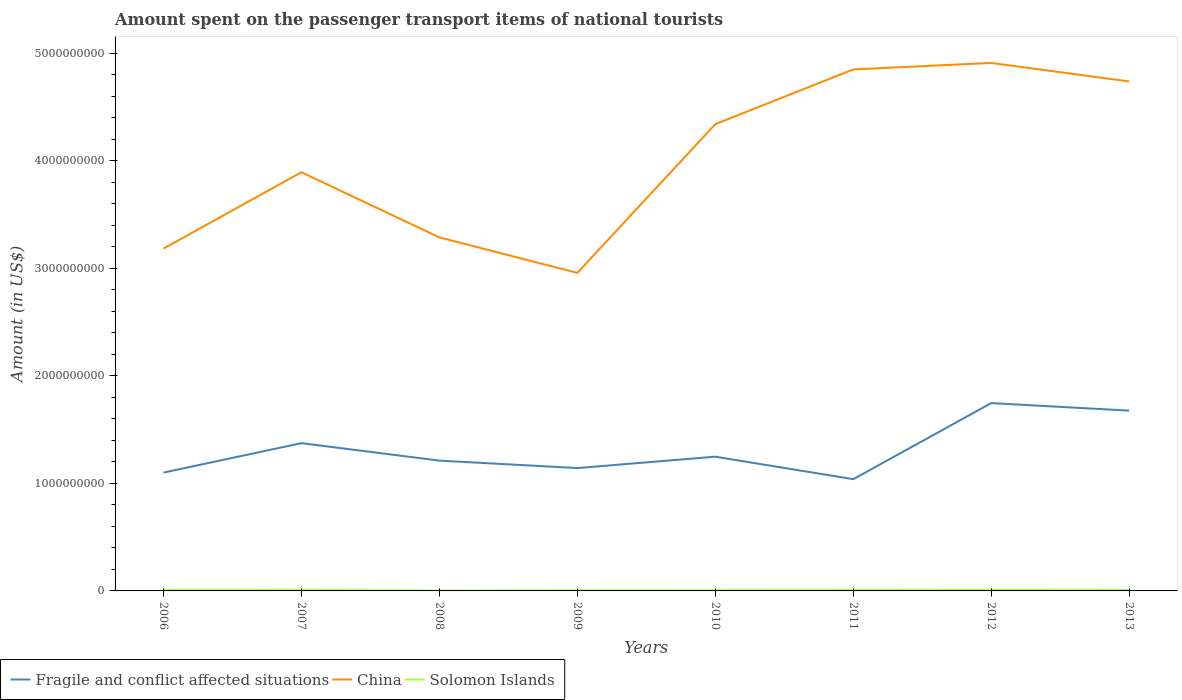Does the line corresponding to Solomon Islands intersect with the line corresponding to China?
Ensure brevity in your answer.  No. Across all years, what is the maximum amount spent on the passenger transport items of national tourists in Fragile and conflict affected situations?
Provide a succinct answer. 1.04e+09. In which year was the amount spent on the passenger transport items of national tourists in Solomon Islands maximum?
Keep it short and to the point. 2008. What is the total amount spent on the passenger transport items of national tourists in Fragile and conflict affected situations in the graph?
Offer a very short reply. 6.92e+07. What is the difference between the highest and the second highest amount spent on the passenger transport items of national tourists in Fragile and conflict affected situations?
Your response must be concise. 7.07e+08. What is the difference between the highest and the lowest amount spent on the passenger transport items of national tourists in Fragile and conflict affected situations?
Provide a succinct answer. 3. How many years are there in the graph?
Your response must be concise. 8. Does the graph contain grids?
Provide a succinct answer. No. How many legend labels are there?
Ensure brevity in your answer.  3. What is the title of the graph?
Offer a terse response. Amount spent on the passenger transport items of national tourists. Does "Iraq" appear as one of the legend labels in the graph?
Offer a terse response. No. What is the label or title of the X-axis?
Provide a short and direct response. Years. What is the label or title of the Y-axis?
Make the answer very short. Amount (in US$). What is the Amount (in US$) of Fragile and conflict affected situations in 2006?
Offer a very short reply. 1.10e+09. What is the Amount (in US$) in China in 2006?
Provide a short and direct response. 3.18e+09. What is the Amount (in US$) in Solomon Islands in 2006?
Offer a very short reply. 9.80e+06. What is the Amount (in US$) in Fragile and conflict affected situations in 2007?
Ensure brevity in your answer.  1.37e+09. What is the Amount (in US$) in China in 2007?
Your response must be concise. 3.89e+09. What is the Amount (in US$) of Solomon Islands in 2007?
Your answer should be very brief. 1.05e+07. What is the Amount (in US$) of Fragile and conflict affected situations in 2008?
Give a very brief answer. 1.21e+09. What is the Amount (in US$) of China in 2008?
Make the answer very short. 3.29e+09. What is the Amount (in US$) in Solomon Islands in 2008?
Ensure brevity in your answer.  3.70e+06. What is the Amount (in US$) of Fragile and conflict affected situations in 2009?
Your response must be concise. 1.14e+09. What is the Amount (in US$) of China in 2009?
Your answer should be very brief. 2.96e+09. What is the Amount (in US$) of Solomon Islands in 2009?
Your response must be concise. 5.90e+06. What is the Amount (in US$) in Fragile and conflict affected situations in 2010?
Offer a very short reply. 1.25e+09. What is the Amount (in US$) in China in 2010?
Provide a succinct answer. 4.34e+09. What is the Amount (in US$) in Solomon Islands in 2010?
Provide a succinct answer. 7.30e+06. What is the Amount (in US$) in Fragile and conflict affected situations in 2011?
Provide a short and direct response. 1.04e+09. What is the Amount (in US$) of China in 2011?
Your answer should be very brief. 4.85e+09. What is the Amount (in US$) of Solomon Islands in 2011?
Your answer should be compact. 8.60e+06. What is the Amount (in US$) in Fragile and conflict affected situations in 2012?
Make the answer very short. 1.75e+09. What is the Amount (in US$) in China in 2012?
Give a very brief answer. 4.91e+09. What is the Amount (in US$) in Solomon Islands in 2012?
Offer a terse response. 1.13e+07. What is the Amount (in US$) of Fragile and conflict affected situations in 2013?
Offer a very short reply. 1.68e+09. What is the Amount (in US$) of China in 2013?
Provide a succinct answer. 4.74e+09. What is the Amount (in US$) in Solomon Islands in 2013?
Your answer should be very brief. 9.00e+06. Across all years, what is the maximum Amount (in US$) in Fragile and conflict affected situations?
Provide a short and direct response. 1.75e+09. Across all years, what is the maximum Amount (in US$) of China?
Make the answer very short. 4.91e+09. Across all years, what is the maximum Amount (in US$) in Solomon Islands?
Make the answer very short. 1.13e+07. Across all years, what is the minimum Amount (in US$) of Fragile and conflict affected situations?
Provide a short and direct response. 1.04e+09. Across all years, what is the minimum Amount (in US$) in China?
Make the answer very short. 2.96e+09. Across all years, what is the minimum Amount (in US$) in Solomon Islands?
Give a very brief answer. 3.70e+06. What is the total Amount (in US$) of Fragile and conflict affected situations in the graph?
Provide a succinct answer. 1.05e+1. What is the total Amount (in US$) in China in the graph?
Provide a succinct answer. 3.22e+1. What is the total Amount (in US$) of Solomon Islands in the graph?
Offer a terse response. 6.61e+07. What is the difference between the Amount (in US$) of Fragile and conflict affected situations in 2006 and that in 2007?
Offer a very short reply. -2.74e+08. What is the difference between the Amount (in US$) in China in 2006 and that in 2007?
Provide a short and direct response. -7.10e+08. What is the difference between the Amount (in US$) of Solomon Islands in 2006 and that in 2007?
Give a very brief answer. -7.00e+05. What is the difference between the Amount (in US$) of Fragile and conflict affected situations in 2006 and that in 2008?
Offer a very short reply. -1.11e+08. What is the difference between the Amount (in US$) of China in 2006 and that in 2008?
Give a very brief answer. -1.04e+08. What is the difference between the Amount (in US$) of Solomon Islands in 2006 and that in 2008?
Give a very brief answer. 6.10e+06. What is the difference between the Amount (in US$) of Fragile and conflict affected situations in 2006 and that in 2009?
Offer a terse response. -4.22e+07. What is the difference between the Amount (in US$) of China in 2006 and that in 2009?
Your answer should be very brief. 2.26e+08. What is the difference between the Amount (in US$) in Solomon Islands in 2006 and that in 2009?
Your answer should be compact. 3.90e+06. What is the difference between the Amount (in US$) in Fragile and conflict affected situations in 2006 and that in 2010?
Offer a terse response. -1.48e+08. What is the difference between the Amount (in US$) of China in 2006 and that in 2010?
Provide a short and direct response. -1.16e+09. What is the difference between the Amount (in US$) of Solomon Islands in 2006 and that in 2010?
Your response must be concise. 2.50e+06. What is the difference between the Amount (in US$) of Fragile and conflict affected situations in 2006 and that in 2011?
Keep it short and to the point. 6.11e+07. What is the difference between the Amount (in US$) of China in 2006 and that in 2011?
Give a very brief answer. -1.67e+09. What is the difference between the Amount (in US$) of Solomon Islands in 2006 and that in 2011?
Give a very brief answer. 1.20e+06. What is the difference between the Amount (in US$) in Fragile and conflict affected situations in 2006 and that in 2012?
Provide a short and direct response. -6.46e+08. What is the difference between the Amount (in US$) of China in 2006 and that in 2012?
Offer a very short reply. -1.73e+09. What is the difference between the Amount (in US$) of Solomon Islands in 2006 and that in 2012?
Offer a terse response. -1.50e+06. What is the difference between the Amount (in US$) in Fragile and conflict affected situations in 2006 and that in 2013?
Keep it short and to the point. -5.76e+08. What is the difference between the Amount (in US$) in China in 2006 and that in 2013?
Keep it short and to the point. -1.55e+09. What is the difference between the Amount (in US$) of Fragile and conflict affected situations in 2007 and that in 2008?
Give a very brief answer. 1.62e+08. What is the difference between the Amount (in US$) in China in 2007 and that in 2008?
Your response must be concise. 6.06e+08. What is the difference between the Amount (in US$) of Solomon Islands in 2007 and that in 2008?
Provide a short and direct response. 6.80e+06. What is the difference between the Amount (in US$) in Fragile and conflict affected situations in 2007 and that in 2009?
Offer a very short reply. 2.32e+08. What is the difference between the Amount (in US$) of China in 2007 and that in 2009?
Offer a terse response. 9.36e+08. What is the difference between the Amount (in US$) in Solomon Islands in 2007 and that in 2009?
Make the answer very short. 4.60e+06. What is the difference between the Amount (in US$) in Fragile and conflict affected situations in 2007 and that in 2010?
Your answer should be compact. 1.26e+08. What is the difference between the Amount (in US$) of China in 2007 and that in 2010?
Make the answer very short. -4.47e+08. What is the difference between the Amount (in US$) in Solomon Islands in 2007 and that in 2010?
Give a very brief answer. 3.20e+06. What is the difference between the Amount (in US$) in Fragile and conflict affected situations in 2007 and that in 2011?
Keep it short and to the point. 3.35e+08. What is the difference between the Amount (in US$) of China in 2007 and that in 2011?
Make the answer very short. -9.56e+08. What is the difference between the Amount (in US$) in Solomon Islands in 2007 and that in 2011?
Provide a succinct answer. 1.90e+06. What is the difference between the Amount (in US$) of Fragile and conflict affected situations in 2007 and that in 2012?
Your response must be concise. -3.72e+08. What is the difference between the Amount (in US$) of China in 2007 and that in 2012?
Provide a short and direct response. -1.02e+09. What is the difference between the Amount (in US$) in Solomon Islands in 2007 and that in 2012?
Keep it short and to the point. -8.00e+05. What is the difference between the Amount (in US$) of Fragile and conflict affected situations in 2007 and that in 2013?
Your answer should be very brief. -3.02e+08. What is the difference between the Amount (in US$) in China in 2007 and that in 2013?
Your response must be concise. -8.44e+08. What is the difference between the Amount (in US$) of Solomon Islands in 2007 and that in 2013?
Offer a very short reply. 1.50e+06. What is the difference between the Amount (in US$) of Fragile and conflict affected situations in 2008 and that in 2009?
Offer a terse response. 6.92e+07. What is the difference between the Amount (in US$) of China in 2008 and that in 2009?
Your response must be concise. 3.30e+08. What is the difference between the Amount (in US$) of Solomon Islands in 2008 and that in 2009?
Offer a very short reply. -2.20e+06. What is the difference between the Amount (in US$) of Fragile and conflict affected situations in 2008 and that in 2010?
Your response must be concise. -3.64e+07. What is the difference between the Amount (in US$) of China in 2008 and that in 2010?
Your answer should be compact. -1.05e+09. What is the difference between the Amount (in US$) in Solomon Islands in 2008 and that in 2010?
Ensure brevity in your answer.  -3.60e+06. What is the difference between the Amount (in US$) in Fragile and conflict affected situations in 2008 and that in 2011?
Your answer should be very brief. 1.73e+08. What is the difference between the Amount (in US$) in China in 2008 and that in 2011?
Offer a terse response. -1.56e+09. What is the difference between the Amount (in US$) of Solomon Islands in 2008 and that in 2011?
Your response must be concise. -4.90e+06. What is the difference between the Amount (in US$) of Fragile and conflict affected situations in 2008 and that in 2012?
Keep it short and to the point. -5.35e+08. What is the difference between the Amount (in US$) of China in 2008 and that in 2012?
Your answer should be compact. -1.62e+09. What is the difference between the Amount (in US$) in Solomon Islands in 2008 and that in 2012?
Keep it short and to the point. -7.60e+06. What is the difference between the Amount (in US$) in Fragile and conflict affected situations in 2008 and that in 2013?
Provide a short and direct response. -4.65e+08. What is the difference between the Amount (in US$) in China in 2008 and that in 2013?
Offer a terse response. -1.45e+09. What is the difference between the Amount (in US$) in Solomon Islands in 2008 and that in 2013?
Offer a very short reply. -5.30e+06. What is the difference between the Amount (in US$) of Fragile and conflict affected situations in 2009 and that in 2010?
Keep it short and to the point. -1.06e+08. What is the difference between the Amount (in US$) of China in 2009 and that in 2010?
Ensure brevity in your answer.  -1.38e+09. What is the difference between the Amount (in US$) of Solomon Islands in 2009 and that in 2010?
Provide a succinct answer. -1.40e+06. What is the difference between the Amount (in US$) of Fragile and conflict affected situations in 2009 and that in 2011?
Your response must be concise. 1.03e+08. What is the difference between the Amount (in US$) in China in 2009 and that in 2011?
Give a very brief answer. -1.89e+09. What is the difference between the Amount (in US$) of Solomon Islands in 2009 and that in 2011?
Your answer should be very brief. -2.70e+06. What is the difference between the Amount (in US$) in Fragile and conflict affected situations in 2009 and that in 2012?
Provide a succinct answer. -6.04e+08. What is the difference between the Amount (in US$) in China in 2009 and that in 2012?
Offer a very short reply. -1.95e+09. What is the difference between the Amount (in US$) in Solomon Islands in 2009 and that in 2012?
Your answer should be compact. -5.40e+06. What is the difference between the Amount (in US$) in Fragile and conflict affected situations in 2009 and that in 2013?
Keep it short and to the point. -5.34e+08. What is the difference between the Amount (in US$) in China in 2009 and that in 2013?
Your answer should be compact. -1.78e+09. What is the difference between the Amount (in US$) in Solomon Islands in 2009 and that in 2013?
Keep it short and to the point. -3.10e+06. What is the difference between the Amount (in US$) in Fragile and conflict affected situations in 2010 and that in 2011?
Give a very brief answer. 2.09e+08. What is the difference between the Amount (in US$) in China in 2010 and that in 2011?
Your answer should be compact. -5.09e+08. What is the difference between the Amount (in US$) in Solomon Islands in 2010 and that in 2011?
Provide a succinct answer. -1.30e+06. What is the difference between the Amount (in US$) of Fragile and conflict affected situations in 2010 and that in 2012?
Your response must be concise. -4.98e+08. What is the difference between the Amount (in US$) in China in 2010 and that in 2012?
Give a very brief answer. -5.69e+08. What is the difference between the Amount (in US$) of Solomon Islands in 2010 and that in 2012?
Give a very brief answer. -4.00e+06. What is the difference between the Amount (in US$) in Fragile and conflict affected situations in 2010 and that in 2013?
Your answer should be compact. -4.28e+08. What is the difference between the Amount (in US$) in China in 2010 and that in 2013?
Give a very brief answer. -3.97e+08. What is the difference between the Amount (in US$) of Solomon Islands in 2010 and that in 2013?
Ensure brevity in your answer.  -1.70e+06. What is the difference between the Amount (in US$) in Fragile and conflict affected situations in 2011 and that in 2012?
Ensure brevity in your answer.  -7.07e+08. What is the difference between the Amount (in US$) of China in 2011 and that in 2012?
Provide a short and direct response. -6.00e+07. What is the difference between the Amount (in US$) in Solomon Islands in 2011 and that in 2012?
Provide a short and direct response. -2.70e+06. What is the difference between the Amount (in US$) in Fragile and conflict affected situations in 2011 and that in 2013?
Provide a short and direct response. -6.37e+08. What is the difference between the Amount (in US$) in China in 2011 and that in 2013?
Keep it short and to the point. 1.12e+08. What is the difference between the Amount (in US$) in Solomon Islands in 2011 and that in 2013?
Your answer should be compact. -4.00e+05. What is the difference between the Amount (in US$) in Fragile and conflict affected situations in 2012 and that in 2013?
Offer a very short reply. 7.01e+07. What is the difference between the Amount (in US$) of China in 2012 and that in 2013?
Give a very brief answer. 1.72e+08. What is the difference between the Amount (in US$) in Solomon Islands in 2012 and that in 2013?
Provide a succinct answer. 2.30e+06. What is the difference between the Amount (in US$) in Fragile and conflict affected situations in 2006 and the Amount (in US$) in China in 2007?
Provide a short and direct response. -2.79e+09. What is the difference between the Amount (in US$) in Fragile and conflict affected situations in 2006 and the Amount (in US$) in Solomon Islands in 2007?
Provide a short and direct response. 1.09e+09. What is the difference between the Amount (in US$) in China in 2006 and the Amount (in US$) in Solomon Islands in 2007?
Make the answer very short. 3.17e+09. What is the difference between the Amount (in US$) of Fragile and conflict affected situations in 2006 and the Amount (in US$) of China in 2008?
Your answer should be very brief. -2.19e+09. What is the difference between the Amount (in US$) of Fragile and conflict affected situations in 2006 and the Amount (in US$) of Solomon Islands in 2008?
Provide a short and direct response. 1.10e+09. What is the difference between the Amount (in US$) in China in 2006 and the Amount (in US$) in Solomon Islands in 2008?
Give a very brief answer. 3.18e+09. What is the difference between the Amount (in US$) of Fragile and conflict affected situations in 2006 and the Amount (in US$) of China in 2009?
Your response must be concise. -1.86e+09. What is the difference between the Amount (in US$) in Fragile and conflict affected situations in 2006 and the Amount (in US$) in Solomon Islands in 2009?
Give a very brief answer. 1.09e+09. What is the difference between the Amount (in US$) of China in 2006 and the Amount (in US$) of Solomon Islands in 2009?
Make the answer very short. 3.18e+09. What is the difference between the Amount (in US$) in Fragile and conflict affected situations in 2006 and the Amount (in US$) in China in 2010?
Your answer should be very brief. -3.24e+09. What is the difference between the Amount (in US$) of Fragile and conflict affected situations in 2006 and the Amount (in US$) of Solomon Islands in 2010?
Offer a terse response. 1.09e+09. What is the difference between the Amount (in US$) in China in 2006 and the Amount (in US$) in Solomon Islands in 2010?
Your response must be concise. 3.18e+09. What is the difference between the Amount (in US$) of Fragile and conflict affected situations in 2006 and the Amount (in US$) of China in 2011?
Make the answer very short. -3.75e+09. What is the difference between the Amount (in US$) of Fragile and conflict affected situations in 2006 and the Amount (in US$) of Solomon Islands in 2011?
Keep it short and to the point. 1.09e+09. What is the difference between the Amount (in US$) in China in 2006 and the Amount (in US$) in Solomon Islands in 2011?
Offer a terse response. 3.17e+09. What is the difference between the Amount (in US$) in Fragile and conflict affected situations in 2006 and the Amount (in US$) in China in 2012?
Provide a succinct answer. -3.81e+09. What is the difference between the Amount (in US$) of Fragile and conflict affected situations in 2006 and the Amount (in US$) of Solomon Islands in 2012?
Make the answer very short. 1.09e+09. What is the difference between the Amount (in US$) in China in 2006 and the Amount (in US$) in Solomon Islands in 2012?
Provide a succinct answer. 3.17e+09. What is the difference between the Amount (in US$) of Fragile and conflict affected situations in 2006 and the Amount (in US$) of China in 2013?
Your response must be concise. -3.64e+09. What is the difference between the Amount (in US$) in Fragile and conflict affected situations in 2006 and the Amount (in US$) in Solomon Islands in 2013?
Your answer should be very brief. 1.09e+09. What is the difference between the Amount (in US$) of China in 2006 and the Amount (in US$) of Solomon Islands in 2013?
Make the answer very short. 3.17e+09. What is the difference between the Amount (in US$) of Fragile and conflict affected situations in 2007 and the Amount (in US$) of China in 2008?
Your answer should be compact. -1.91e+09. What is the difference between the Amount (in US$) of Fragile and conflict affected situations in 2007 and the Amount (in US$) of Solomon Islands in 2008?
Keep it short and to the point. 1.37e+09. What is the difference between the Amount (in US$) of China in 2007 and the Amount (in US$) of Solomon Islands in 2008?
Provide a short and direct response. 3.89e+09. What is the difference between the Amount (in US$) in Fragile and conflict affected situations in 2007 and the Amount (in US$) in China in 2009?
Offer a very short reply. -1.58e+09. What is the difference between the Amount (in US$) of Fragile and conflict affected situations in 2007 and the Amount (in US$) of Solomon Islands in 2009?
Your answer should be very brief. 1.37e+09. What is the difference between the Amount (in US$) of China in 2007 and the Amount (in US$) of Solomon Islands in 2009?
Keep it short and to the point. 3.89e+09. What is the difference between the Amount (in US$) of Fragile and conflict affected situations in 2007 and the Amount (in US$) of China in 2010?
Keep it short and to the point. -2.97e+09. What is the difference between the Amount (in US$) in Fragile and conflict affected situations in 2007 and the Amount (in US$) in Solomon Islands in 2010?
Offer a very short reply. 1.37e+09. What is the difference between the Amount (in US$) of China in 2007 and the Amount (in US$) of Solomon Islands in 2010?
Your answer should be very brief. 3.89e+09. What is the difference between the Amount (in US$) in Fragile and conflict affected situations in 2007 and the Amount (in US$) in China in 2011?
Ensure brevity in your answer.  -3.48e+09. What is the difference between the Amount (in US$) of Fragile and conflict affected situations in 2007 and the Amount (in US$) of Solomon Islands in 2011?
Your answer should be very brief. 1.37e+09. What is the difference between the Amount (in US$) in China in 2007 and the Amount (in US$) in Solomon Islands in 2011?
Offer a very short reply. 3.88e+09. What is the difference between the Amount (in US$) of Fragile and conflict affected situations in 2007 and the Amount (in US$) of China in 2012?
Your answer should be compact. -3.54e+09. What is the difference between the Amount (in US$) of Fragile and conflict affected situations in 2007 and the Amount (in US$) of Solomon Islands in 2012?
Give a very brief answer. 1.36e+09. What is the difference between the Amount (in US$) in China in 2007 and the Amount (in US$) in Solomon Islands in 2012?
Your response must be concise. 3.88e+09. What is the difference between the Amount (in US$) of Fragile and conflict affected situations in 2007 and the Amount (in US$) of China in 2013?
Your answer should be compact. -3.36e+09. What is the difference between the Amount (in US$) in Fragile and conflict affected situations in 2007 and the Amount (in US$) in Solomon Islands in 2013?
Your answer should be compact. 1.36e+09. What is the difference between the Amount (in US$) of China in 2007 and the Amount (in US$) of Solomon Islands in 2013?
Make the answer very short. 3.88e+09. What is the difference between the Amount (in US$) in Fragile and conflict affected situations in 2008 and the Amount (in US$) in China in 2009?
Provide a short and direct response. -1.75e+09. What is the difference between the Amount (in US$) in Fragile and conflict affected situations in 2008 and the Amount (in US$) in Solomon Islands in 2009?
Your answer should be compact. 1.21e+09. What is the difference between the Amount (in US$) of China in 2008 and the Amount (in US$) of Solomon Islands in 2009?
Your answer should be very brief. 3.28e+09. What is the difference between the Amount (in US$) in Fragile and conflict affected situations in 2008 and the Amount (in US$) in China in 2010?
Keep it short and to the point. -3.13e+09. What is the difference between the Amount (in US$) of Fragile and conflict affected situations in 2008 and the Amount (in US$) of Solomon Islands in 2010?
Give a very brief answer. 1.20e+09. What is the difference between the Amount (in US$) in China in 2008 and the Amount (in US$) in Solomon Islands in 2010?
Give a very brief answer. 3.28e+09. What is the difference between the Amount (in US$) in Fragile and conflict affected situations in 2008 and the Amount (in US$) in China in 2011?
Give a very brief answer. -3.64e+09. What is the difference between the Amount (in US$) in Fragile and conflict affected situations in 2008 and the Amount (in US$) in Solomon Islands in 2011?
Give a very brief answer. 1.20e+09. What is the difference between the Amount (in US$) in China in 2008 and the Amount (in US$) in Solomon Islands in 2011?
Make the answer very short. 3.28e+09. What is the difference between the Amount (in US$) in Fragile and conflict affected situations in 2008 and the Amount (in US$) in China in 2012?
Provide a short and direct response. -3.70e+09. What is the difference between the Amount (in US$) of Fragile and conflict affected situations in 2008 and the Amount (in US$) of Solomon Islands in 2012?
Give a very brief answer. 1.20e+09. What is the difference between the Amount (in US$) of China in 2008 and the Amount (in US$) of Solomon Islands in 2012?
Provide a short and direct response. 3.28e+09. What is the difference between the Amount (in US$) of Fragile and conflict affected situations in 2008 and the Amount (in US$) of China in 2013?
Keep it short and to the point. -3.53e+09. What is the difference between the Amount (in US$) in Fragile and conflict affected situations in 2008 and the Amount (in US$) in Solomon Islands in 2013?
Your response must be concise. 1.20e+09. What is the difference between the Amount (in US$) in China in 2008 and the Amount (in US$) in Solomon Islands in 2013?
Give a very brief answer. 3.28e+09. What is the difference between the Amount (in US$) of Fragile and conflict affected situations in 2009 and the Amount (in US$) of China in 2010?
Provide a short and direct response. -3.20e+09. What is the difference between the Amount (in US$) of Fragile and conflict affected situations in 2009 and the Amount (in US$) of Solomon Islands in 2010?
Provide a succinct answer. 1.14e+09. What is the difference between the Amount (in US$) in China in 2009 and the Amount (in US$) in Solomon Islands in 2010?
Your answer should be compact. 2.95e+09. What is the difference between the Amount (in US$) of Fragile and conflict affected situations in 2009 and the Amount (in US$) of China in 2011?
Give a very brief answer. -3.71e+09. What is the difference between the Amount (in US$) of Fragile and conflict affected situations in 2009 and the Amount (in US$) of Solomon Islands in 2011?
Keep it short and to the point. 1.13e+09. What is the difference between the Amount (in US$) in China in 2009 and the Amount (in US$) in Solomon Islands in 2011?
Give a very brief answer. 2.95e+09. What is the difference between the Amount (in US$) of Fragile and conflict affected situations in 2009 and the Amount (in US$) of China in 2012?
Give a very brief answer. -3.77e+09. What is the difference between the Amount (in US$) of Fragile and conflict affected situations in 2009 and the Amount (in US$) of Solomon Islands in 2012?
Your response must be concise. 1.13e+09. What is the difference between the Amount (in US$) of China in 2009 and the Amount (in US$) of Solomon Islands in 2012?
Keep it short and to the point. 2.95e+09. What is the difference between the Amount (in US$) of Fragile and conflict affected situations in 2009 and the Amount (in US$) of China in 2013?
Give a very brief answer. -3.59e+09. What is the difference between the Amount (in US$) in Fragile and conflict affected situations in 2009 and the Amount (in US$) in Solomon Islands in 2013?
Keep it short and to the point. 1.13e+09. What is the difference between the Amount (in US$) in China in 2009 and the Amount (in US$) in Solomon Islands in 2013?
Offer a very short reply. 2.95e+09. What is the difference between the Amount (in US$) in Fragile and conflict affected situations in 2010 and the Amount (in US$) in China in 2011?
Ensure brevity in your answer.  -3.60e+09. What is the difference between the Amount (in US$) of Fragile and conflict affected situations in 2010 and the Amount (in US$) of Solomon Islands in 2011?
Provide a succinct answer. 1.24e+09. What is the difference between the Amount (in US$) in China in 2010 and the Amount (in US$) in Solomon Islands in 2011?
Provide a succinct answer. 4.33e+09. What is the difference between the Amount (in US$) in Fragile and conflict affected situations in 2010 and the Amount (in US$) in China in 2012?
Offer a terse response. -3.66e+09. What is the difference between the Amount (in US$) of Fragile and conflict affected situations in 2010 and the Amount (in US$) of Solomon Islands in 2012?
Your answer should be compact. 1.24e+09. What is the difference between the Amount (in US$) of China in 2010 and the Amount (in US$) of Solomon Islands in 2012?
Make the answer very short. 4.33e+09. What is the difference between the Amount (in US$) of Fragile and conflict affected situations in 2010 and the Amount (in US$) of China in 2013?
Make the answer very short. -3.49e+09. What is the difference between the Amount (in US$) in Fragile and conflict affected situations in 2010 and the Amount (in US$) in Solomon Islands in 2013?
Provide a short and direct response. 1.24e+09. What is the difference between the Amount (in US$) of China in 2010 and the Amount (in US$) of Solomon Islands in 2013?
Make the answer very short. 4.33e+09. What is the difference between the Amount (in US$) of Fragile and conflict affected situations in 2011 and the Amount (in US$) of China in 2012?
Your answer should be compact. -3.87e+09. What is the difference between the Amount (in US$) in Fragile and conflict affected situations in 2011 and the Amount (in US$) in Solomon Islands in 2012?
Provide a succinct answer. 1.03e+09. What is the difference between the Amount (in US$) in China in 2011 and the Amount (in US$) in Solomon Islands in 2012?
Keep it short and to the point. 4.84e+09. What is the difference between the Amount (in US$) in Fragile and conflict affected situations in 2011 and the Amount (in US$) in China in 2013?
Make the answer very short. -3.70e+09. What is the difference between the Amount (in US$) in Fragile and conflict affected situations in 2011 and the Amount (in US$) in Solomon Islands in 2013?
Provide a short and direct response. 1.03e+09. What is the difference between the Amount (in US$) in China in 2011 and the Amount (in US$) in Solomon Islands in 2013?
Your answer should be compact. 4.84e+09. What is the difference between the Amount (in US$) of Fragile and conflict affected situations in 2012 and the Amount (in US$) of China in 2013?
Make the answer very short. -2.99e+09. What is the difference between the Amount (in US$) in Fragile and conflict affected situations in 2012 and the Amount (in US$) in Solomon Islands in 2013?
Your answer should be very brief. 1.74e+09. What is the difference between the Amount (in US$) of China in 2012 and the Amount (in US$) of Solomon Islands in 2013?
Offer a very short reply. 4.90e+09. What is the average Amount (in US$) of Fragile and conflict affected situations per year?
Ensure brevity in your answer.  1.32e+09. What is the average Amount (in US$) in China per year?
Your response must be concise. 4.02e+09. What is the average Amount (in US$) of Solomon Islands per year?
Give a very brief answer. 8.26e+06. In the year 2006, what is the difference between the Amount (in US$) of Fragile and conflict affected situations and Amount (in US$) of China?
Your answer should be very brief. -2.08e+09. In the year 2006, what is the difference between the Amount (in US$) in Fragile and conflict affected situations and Amount (in US$) in Solomon Islands?
Ensure brevity in your answer.  1.09e+09. In the year 2006, what is the difference between the Amount (in US$) of China and Amount (in US$) of Solomon Islands?
Your answer should be compact. 3.17e+09. In the year 2007, what is the difference between the Amount (in US$) in Fragile and conflict affected situations and Amount (in US$) in China?
Keep it short and to the point. -2.52e+09. In the year 2007, what is the difference between the Amount (in US$) in Fragile and conflict affected situations and Amount (in US$) in Solomon Islands?
Keep it short and to the point. 1.36e+09. In the year 2007, what is the difference between the Amount (in US$) in China and Amount (in US$) in Solomon Islands?
Make the answer very short. 3.88e+09. In the year 2008, what is the difference between the Amount (in US$) of Fragile and conflict affected situations and Amount (in US$) of China?
Your answer should be very brief. -2.08e+09. In the year 2008, what is the difference between the Amount (in US$) of Fragile and conflict affected situations and Amount (in US$) of Solomon Islands?
Provide a succinct answer. 1.21e+09. In the year 2008, what is the difference between the Amount (in US$) of China and Amount (in US$) of Solomon Islands?
Your answer should be very brief. 3.28e+09. In the year 2009, what is the difference between the Amount (in US$) in Fragile and conflict affected situations and Amount (in US$) in China?
Your answer should be very brief. -1.81e+09. In the year 2009, what is the difference between the Amount (in US$) in Fragile and conflict affected situations and Amount (in US$) in Solomon Islands?
Offer a terse response. 1.14e+09. In the year 2009, what is the difference between the Amount (in US$) in China and Amount (in US$) in Solomon Islands?
Offer a terse response. 2.95e+09. In the year 2010, what is the difference between the Amount (in US$) of Fragile and conflict affected situations and Amount (in US$) of China?
Your response must be concise. -3.09e+09. In the year 2010, what is the difference between the Amount (in US$) in Fragile and conflict affected situations and Amount (in US$) in Solomon Islands?
Your answer should be compact. 1.24e+09. In the year 2010, what is the difference between the Amount (in US$) in China and Amount (in US$) in Solomon Islands?
Your answer should be compact. 4.33e+09. In the year 2011, what is the difference between the Amount (in US$) in Fragile and conflict affected situations and Amount (in US$) in China?
Ensure brevity in your answer.  -3.81e+09. In the year 2011, what is the difference between the Amount (in US$) in Fragile and conflict affected situations and Amount (in US$) in Solomon Islands?
Offer a very short reply. 1.03e+09. In the year 2011, what is the difference between the Amount (in US$) of China and Amount (in US$) of Solomon Islands?
Offer a very short reply. 4.84e+09. In the year 2012, what is the difference between the Amount (in US$) in Fragile and conflict affected situations and Amount (in US$) in China?
Offer a very short reply. -3.16e+09. In the year 2012, what is the difference between the Amount (in US$) of Fragile and conflict affected situations and Amount (in US$) of Solomon Islands?
Offer a very short reply. 1.74e+09. In the year 2012, what is the difference between the Amount (in US$) of China and Amount (in US$) of Solomon Islands?
Provide a short and direct response. 4.90e+09. In the year 2013, what is the difference between the Amount (in US$) in Fragile and conflict affected situations and Amount (in US$) in China?
Provide a succinct answer. -3.06e+09. In the year 2013, what is the difference between the Amount (in US$) in Fragile and conflict affected situations and Amount (in US$) in Solomon Islands?
Offer a very short reply. 1.67e+09. In the year 2013, what is the difference between the Amount (in US$) of China and Amount (in US$) of Solomon Islands?
Provide a short and direct response. 4.73e+09. What is the ratio of the Amount (in US$) in Fragile and conflict affected situations in 2006 to that in 2007?
Your answer should be very brief. 0.8. What is the ratio of the Amount (in US$) in China in 2006 to that in 2007?
Offer a terse response. 0.82. What is the ratio of the Amount (in US$) of Fragile and conflict affected situations in 2006 to that in 2008?
Offer a very short reply. 0.91. What is the ratio of the Amount (in US$) in China in 2006 to that in 2008?
Keep it short and to the point. 0.97. What is the ratio of the Amount (in US$) of Solomon Islands in 2006 to that in 2008?
Your answer should be very brief. 2.65. What is the ratio of the Amount (in US$) in Fragile and conflict affected situations in 2006 to that in 2009?
Ensure brevity in your answer.  0.96. What is the ratio of the Amount (in US$) in China in 2006 to that in 2009?
Your answer should be compact. 1.08. What is the ratio of the Amount (in US$) of Solomon Islands in 2006 to that in 2009?
Make the answer very short. 1.66. What is the ratio of the Amount (in US$) in Fragile and conflict affected situations in 2006 to that in 2010?
Your answer should be very brief. 0.88. What is the ratio of the Amount (in US$) in China in 2006 to that in 2010?
Keep it short and to the point. 0.73. What is the ratio of the Amount (in US$) of Solomon Islands in 2006 to that in 2010?
Give a very brief answer. 1.34. What is the ratio of the Amount (in US$) of Fragile and conflict affected situations in 2006 to that in 2011?
Provide a succinct answer. 1.06. What is the ratio of the Amount (in US$) in China in 2006 to that in 2011?
Ensure brevity in your answer.  0.66. What is the ratio of the Amount (in US$) of Solomon Islands in 2006 to that in 2011?
Your answer should be compact. 1.14. What is the ratio of the Amount (in US$) of Fragile and conflict affected situations in 2006 to that in 2012?
Your answer should be very brief. 0.63. What is the ratio of the Amount (in US$) of China in 2006 to that in 2012?
Ensure brevity in your answer.  0.65. What is the ratio of the Amount (in US$) in Solomon Islands in 2006 to that in 2012?
Provide a short and direct response. 0.87. What is the ratio of the Amount (in US$) in Fragile and conflict affected situations in 2006 to that in 2013?
Offer a terse response. 0.66. What is the ratio of the Amount (in US$) in China in 2006 to that in 2013?
Give a very brief answer. 0.67. What is the ratio of the Amount (in US$) in Solomon Islands in 2006 to that in 2013?
Give a very brief answer. 1.09. What is the ratio of the Amount (in US$) of Fragile and conflict affected situations in 2007 to that in 2008?
Keep it short and to the point. 1.13. What is the ratio of the Amount (in US$) of China in 2007 to that in 2008?
Provide a short and direct response. 1.18. What is the ratio of the Amount (in US$) of Solomon Islands in 2007 to that in 2008?
Provide a short and direct response. 2.84. What is the ratio of the Amount (in US$) of Fragile and conflict affected situations in 2007 to that in 2009?
Give a very brief answer. 1.2. What is the ratio of the Amount (in US$) of China in 2007 to that in 2009?
Your answer should be very brief. 1.32. What is the ratio of the Amount (in US$) in Solomon Islands in 2007 to that in 2009?
Your answer should be very brief. 1.78. What is the ratio of the Amount (in US$) in Fragile and conflict affected situations in 2007 to that in 2010?
Provide a succinct answer. 1.1. What is the ratio of the Amount (in US$) of China in 2007 to that in 2010?
Your answer should be very brief. 0.9. What is the ratio of the Amount (in US$) in Solomon Islands in 2007 to that in 2010?
Ensure brevity in your answer.  1.44. What is the ratio of the Amount (in US$) in Fragile and conflict affected situations in 2007 to that in 2011?
Provide a succinct answer. 1.32. What is the ratio of the Amount (in US$) of China in 2007 to that in 2011?
Keep it short and to the point. 0.8. What is the ratio of the Amount (in US$) of Solomon Islands in 2007 to that in 2011?
Provide a succinct answer. 1.22. What is the ratio of the Amount (in US$) in Fragile and conflict affected situations in 2007 to that in 2012?
Keep it short and to the point. 0.79. What is the ratio of the Amount (in US$) of China in 2007 to that in 2012?
Offer a very short reply. 0.79. What is the ratio of the Amount (in US$) of Solomon Islands in 2007 to that in 2012?
Your response must be concise. 0.93. What is the ratio of the Amount (in US$) in Fragile and conflict affected situations in 2007 to that in 2013?
Keep it short and to the point. 0.82. What is the ratio of the Amount (in US$) of China in 2007 to that in 2013?
Offer a terse response. 0.82. What is the ratio of the Amount (in US$) of Solomon Islands in 2007 to that in 2013?
Provide a succinct answer. 1.17. What is the ratio of the Amount (in US$) of Fragile and conflict affected situations in 2008 to that in 2009?
Make the answer very short. 1.06. What is the ratio of the Amount (in US$) in China in 2008 to that in 2009?
Offer a very short reply. 1.11. What is the ratio of the Amount (in US$) in Solomon Islands in 2008 to that in 2009?
Keep it short and to the point. 0.63. What is the ratio of the Amount (in US$) in Fragile and conflict affected situations in 2008 to that in 2010?
Provide a short and direct response. 0.97. What is the ratio of the Amount (in US$) in China in 2008 to that in 2010?
Provide a succinct answer. 0.76. What is the ratio of the Amount (in US$) in Solomon Islands in 2008 to that in 2010?
Provide a short and direct response. 0.51. What is the ratio of the Amount (in US$) of Fragile and conflict affected situations in 2008 to that in 2011?
Keep it short and to the point. 1.17. What is the ratio of the Amount (in US$) of China in 2008 to that in 2011?
Your answer should be compact. 0.68. What is the ratio of the Amount (in US$) in Solomon Islands in 2008 to that in 2011?
Your answer should be compact. 0.43. What is the ratio of the Amount (in US$) of Fragile and conflict affected situations in 2008 to that in 2012?
Your answer should be very brief. 0.69. What is the ratio of the Amount (in US$) of China in 2008 to that in 2012?
Your answer should be compact. 0.67. What is the ratio of the Amount (in US$) of Solomon Islands in 2008 to that in 2012?
Make the answer very short. 0.33. What is the ratio of the Amount (in US$) in Fragile and conflict affected situations in 2008 to that in 2013?
Ensure brevity in your answer.  0.72. What is the ratio of the Amount (in US$) in China in 2008 to that in 2013?
Make the answer very short. 0.69. What is the ratio of the Amount (in US$) of Solomon Islands in 2008 to that in 2013?
Ensure brevity in your answer.  0.41. What is the ratio of the Amount (in US$) in Fragile and conflict affected situations in 2009 to that in 2010?
Your answer should be compact. 0.92. What is the ratio of the Amount (in US$) of China in 2009 to that in 2010?
Your answer should be very brief. 0.68. What is the ratio of the Amount (in US$) in Solomon Islands in 2009 to that in 2010?
Your response must be concise. 0.81. What is the ratio of the Amount (in US$) of Fragile and conflict affected situations in 2009 to that in 2011?
Give a very brief answer. 1.1. What is the ratio of the Amount (in US$) of China in 2009 to that in 2011?
Ensure brevity in your answer.  0.61. What is the ratio of the Amount (in US$) in Solomon Islands in 2009 to that in 2011?
Give a very brief answer. 0.69. What is the ratio of the Amount (in US$) of Fragile and conflict affected situations in 2009 to that in 2012?
Ensure brevity in your answer.  0.65. What is the ratio of the Amount (in US$) in China in 2009 to that in 2012?
Your response must be concise. 0.6. What is the ratio of the Amount (in US$) in Solomon Islands in 2009 to that in 2012?
Ensure brevity in your answer.  0.52. What is the ratio of the Amount (in US$) in Fragile and conflict affected situations in 2009 to that in 2013?
Your response must be concise. 0.68. What is the ratio of the Amount (in US$) of China in 2009 to that in 2013?
Ensure brevity in your answer.  0.62. What is the ratio of the Amount (in US$) of Solomon Islands in 2009 to that in 2013?
Offer a very short reply. 0.66. What is the ratio of the Amount (in US$) in Fragile and conflict affected situations in 2010 to that in 2011?
Ensure brevity in your answer.  1.2. What is the ratio of the Amount (in US$) of China in 2010 to that in 2011?
Provide a short and direct response. 0.9. What is the ratio of the Amount (in US$) of Solomon Islands in 2010 to that in 2011?
Make the answer very short. 0.85. What is the ratio of the Amount (in US$) of Fragile and conflict affected situations in 2010 to that in 2012?
Provide a short and direct response. 0.71. What is the ratio of the Amount (in US$) in China in 2010 to that in 2012?
Provide a short and direct response. 0.88. What is the ratio of the Amount (in US$) in Solomon Islands in 2010 to that in 2012?
Your answer should be very brief. 0.65. What is the ratio of the Amount (in US$) in Fragile and conflict affected situations in 2010 to that in 2013?
Ensure brevity in your answer.  0.74. What is the ratio of the Amount (in US$) in China in 2010 to that in 2013?
Provide a short and direct response. 0.92. What is the ratio of the Amount (in US$) in Solomon Islands in 2010 to that in 2013?
Offer a terse response. 0.81. What is the ratio of the Amount (in US$) of Fragile and conflict affected situations in 2011 to that in 2012?
Your answer should be compact. 0.59. What is the ratio of the Amount (in US$) in Solomon Islands in 2011 to that in 2012?
Offer a terse response. 0.76. What is the ratio of the Amount (in US$) of Fragile and conflict affected situations in 2011 to that in 2013?
Your answer should be compact. 0.62. What is the ratio of the Amount (in US$) in China in 2011 to that in 2013?
Provide a succinct answer. 1.02. What is the ratio of the Amount (in US$) in Solomon Islands in 2011 to that in 2013?
Your response must be concise. 0.96. What is the ratio of the Amount (in US$) in Fragile and conflict affected situations in 2012 to that in 2013?
Your response must be concise. 1.04. What is the ratio of the Amount (in US$) in China in 2012 to that in 2013?
Ensure brevity in your answer.  1.04. What is the ratio of the Amount (in US$) of Solomon Islands in 2012 to that in 2013?
Provide a succinct answer. 1.26. What is the difference between the highest and the second highest Amount (in US$) in Fragile and conflict affected situations?
Provide a succinct answer. 7.01e+07. What is the difference between the highest and the second highest Amount (in US$) in China?
Provide a succinct answer. 6.00e+07. What is the difference between the highest and the second highest Amount (in US$) in Solomon Islands?
Make the answer very short. 8.00e+05. What is the difference between the highest and the lowest Amount (in US$) in Fragile and conflict affected situations?
Ensure brevity in your answer.  7.07e+08. What is the difference between the highest and the lowest Amount (in US$) of China?
Your response must be concise. 1.95e+09. What is the difference between the highest and the lowest Amount (in US$) in Solomon Islands?
Provide a short and direct response. 7.60e+06. 